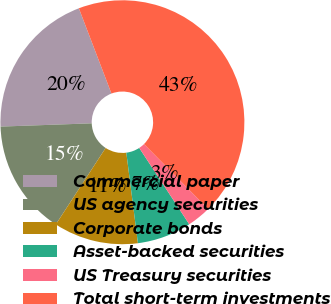<chart> <loc_0><loc_0><loc_500><loc_500><pie_chart><fcel>Commercial paper<fcel>US agency securities<fcel>Corporate bonds<fcel>Asset-backed securities<fcel>US Treasury securities<fcel>Total short-term investments<nl><fcel>19.76%<fcel>15.24%<fcel>11.22%<fcel>7.2%<fcel>3.17%<fcel>43.41%<nl></chart> 